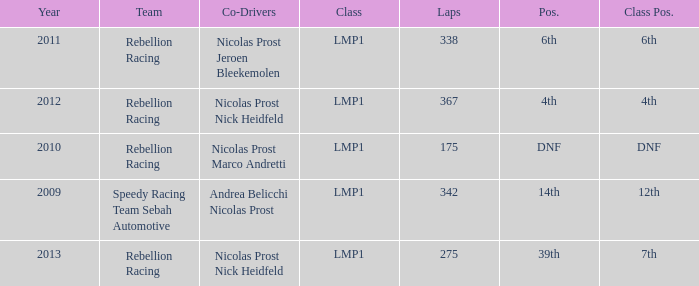What is Class Pos., when Year is before 2013, and when Laps is greater than 175? 12th, 6th, 4th. 